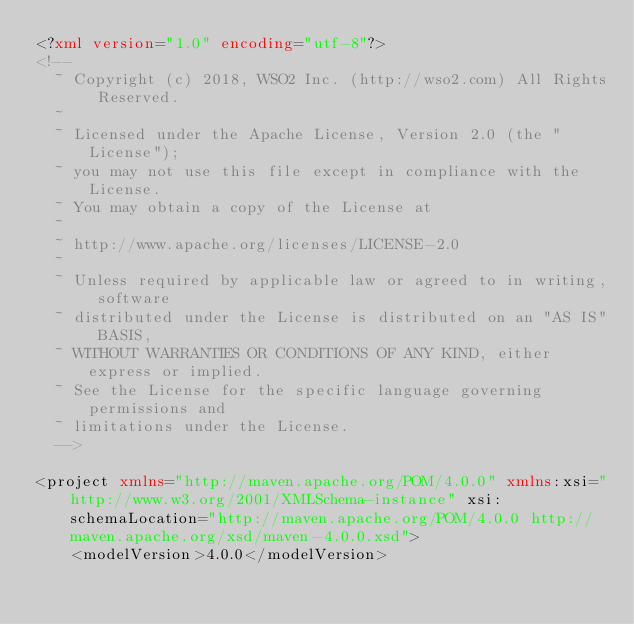<code> <loc_0><loc_0><loc_500><loc_500><_XML_><?xml version="1.0" encoding="utf-8"?>
<!--
  ~ Copyright (c) 2018, WSO2 Inc. (http://wso2.com) All Rights Reserved.
  ~
  ~ Licensed under the Apache License, Version 2.0 (the "License");
  ~ you may not use this file except in compliance with the License.
  ~ You may obtain a copy of the License at
  ~
  ~ http://www.apache.org/licenses/LICENSE-2.0
  ~
  ~ Unless required by applicable law or agreed to in writing, software
  ~ distributed under the License is distributed on an "AS IS" BASIS,
  ~ WITHOUT WARRANTIES OR CONDITIONS OF ANY KIND, either express or implied.
  ~ See the License for the specific language governing permissions and
  ~ limitations under the License.
  -->

<project xmlns="http://maven.apache.org/POM/4.0.0" xmlns:xsi="http://www.w3.org/2001/XMLSchema-instance" xsi:schemaLocation="http://maven.apache.org/POM/4.0.0 http://maven.apache.org/xsd/maven-4.0.0.xsd">
    <modelVersion>4.0.0</modelVersion>
</code> 